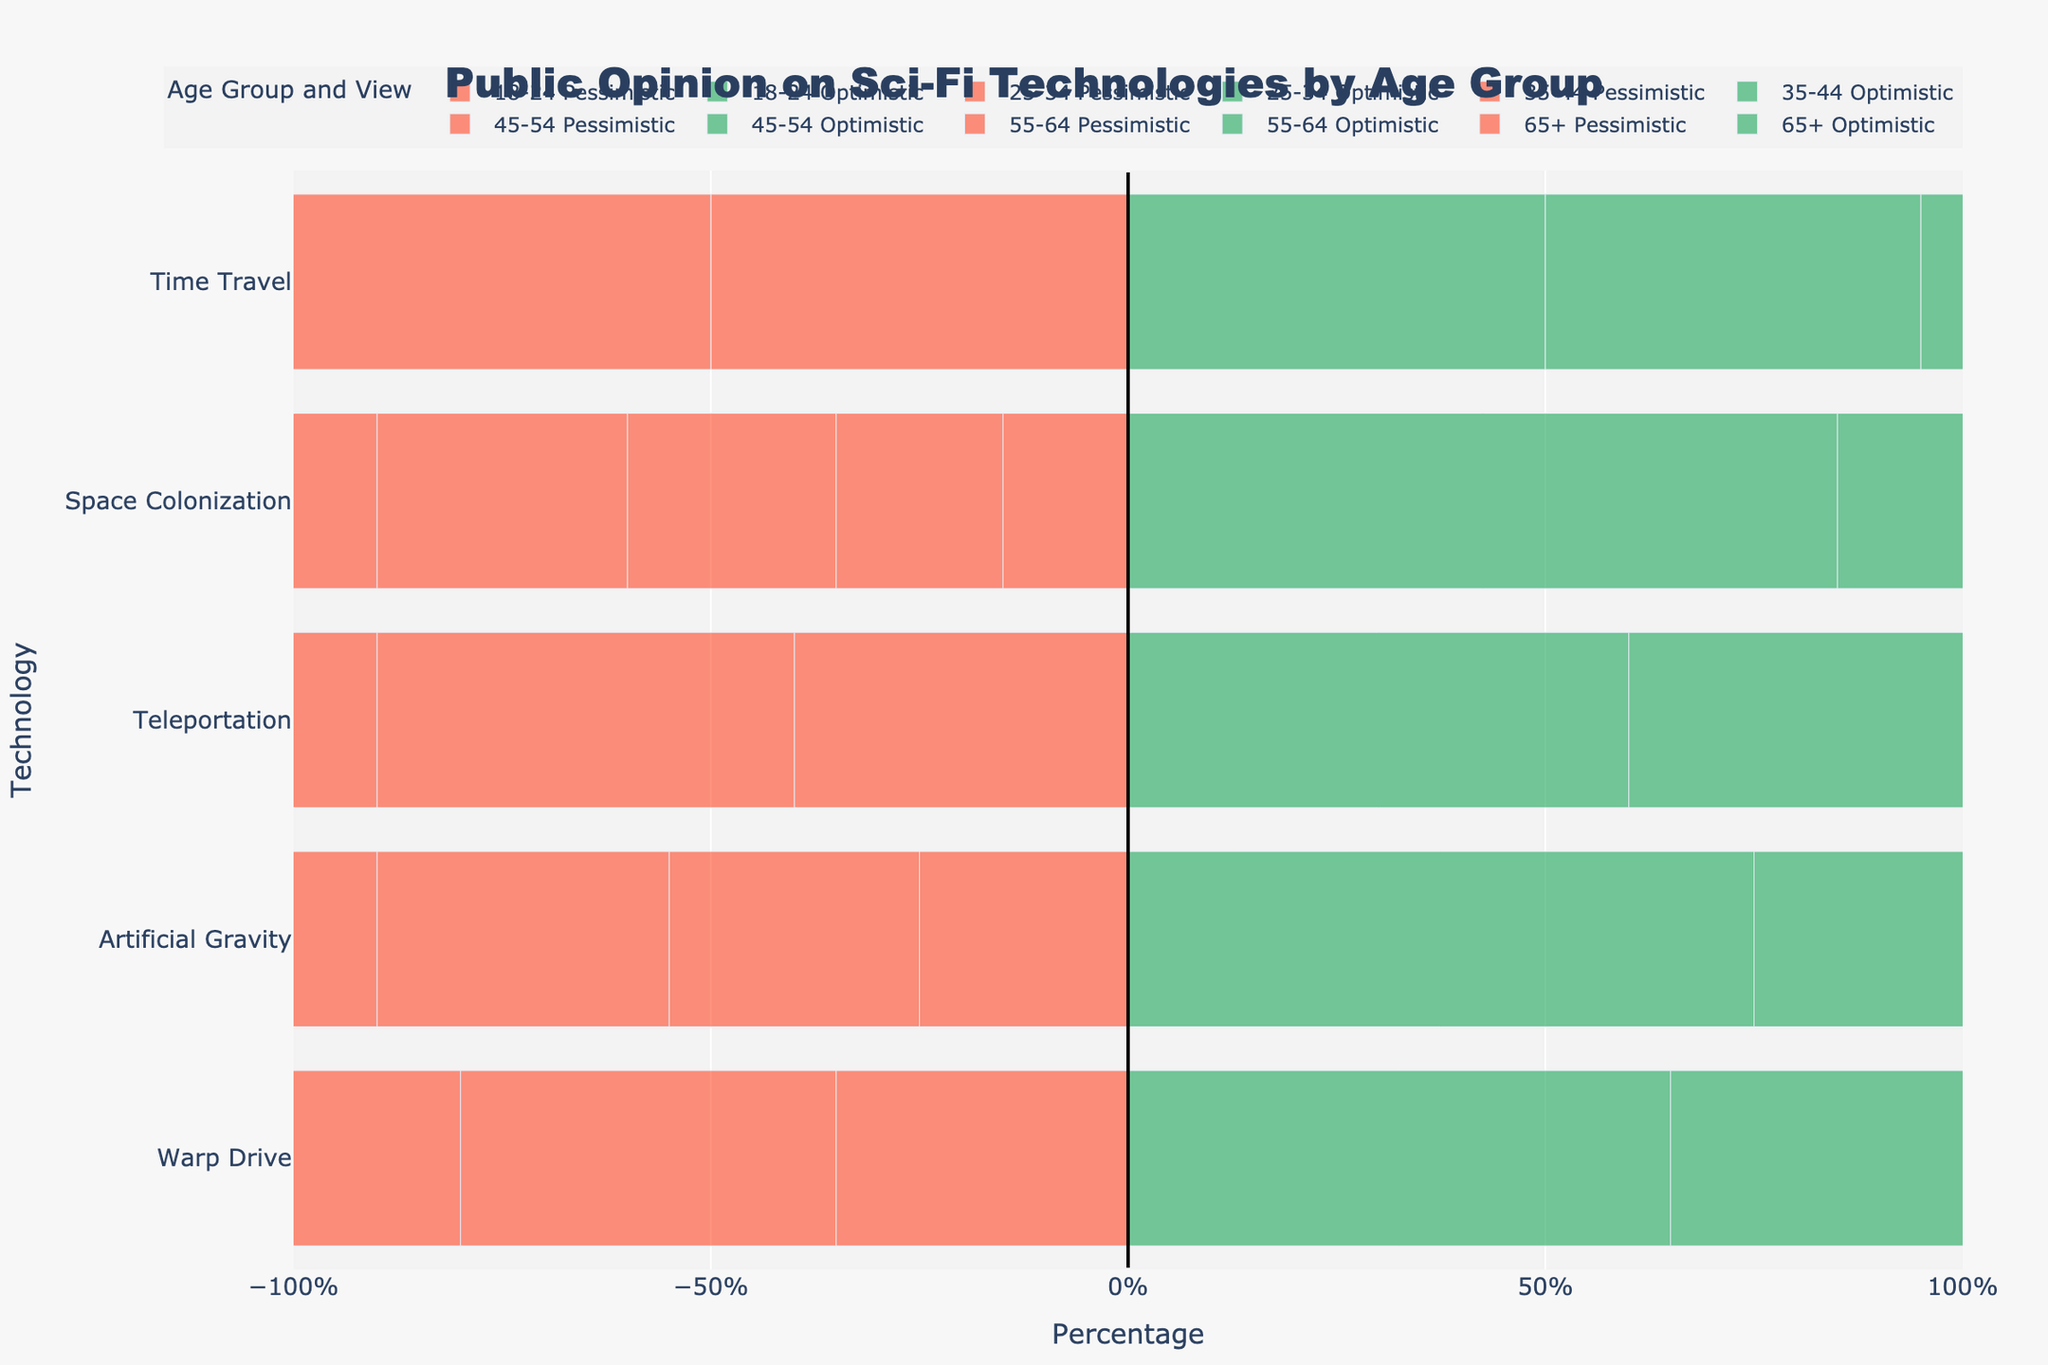What's the most optimistic age group for Space Colonization? The optimistic views for Space Colonization by age group are 85% for 18-24, 80% for 25-34, 75% for 35-44, 70% for 45-54, 65% for 55-64, and 60% for 65+. The highest optimistic view is 85% from the 18-24 age group.
Answer: 18-24 Which technology has the largest difference in optimistic views between the 18-24 and 65+ age groups? Compare the optimistic views for each technology between the 18-24 and 65+ age groups: Warp Drive (65%-35%=30%), Artificial Gravity (75%-50%=25%), Teleportation (60%-30%=30%), Space Colonization (85%-60%=25%), and Time Travel (50%-25%=25%). The largest differences are for Warp Drive and Teleportation, both 30%.
Answer: Warp Drive and Teleportation Which age group has the highest pessimistic view on Time Travel? The pessimistic views for Time Travel are 50% (18-24), 55% (25-34), 60% (35-44), 65% (45-54), 70% (55-64), and 75% (65+). The highest pessimistic view is from the 65+ age group at 75%.
Answer: 65+ What is the average optimistic view for Artificial Gravity across all age groups? Sum the optimistic views for Artificial Gravity: 75% + 70% + 65% + 60% + 55% + 50% = 375%. Divide by the number of age groups (6): 375% / 6 = 62.5%.
Answer: 62.5% Which technology has the lowest optimistic view from the 35-44 age group? The optimistic views for the 35-44 age group are: Warp Drive (50%), Artificial Gravity (65%), Teleportation (45%), Space Colonization (75%), and Time Travel (40%). The lowest optimistic view is for Time Travel at 40%.
Answer: Time Travel 